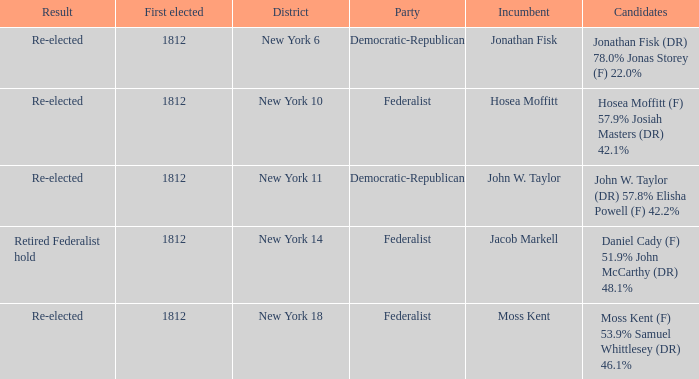Name the first elected for hosea moffitt (f) 57.9% josiah masters (dr) 42.1% 1812.0. 